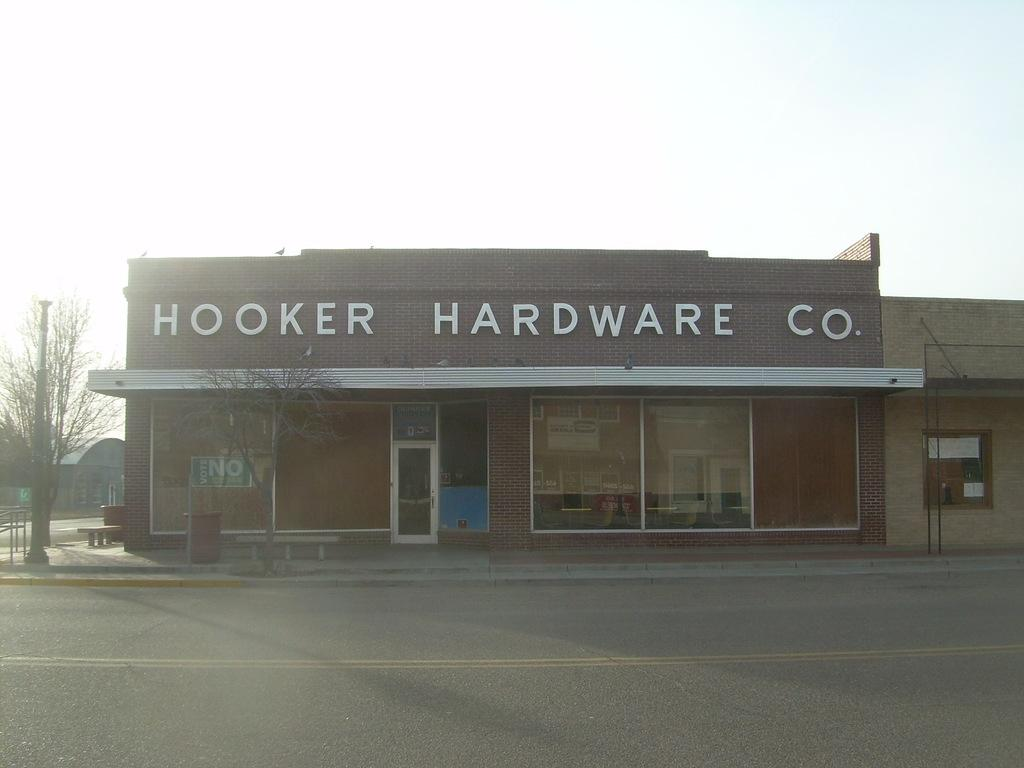What type of structures can be seen in the image? There are buildings in the image. Can you identify any specific details about one of the buildings? One of the buildings has a name on it. What type of vegetation is present in the image? There are trees in the image. What type of pathway is visible in the image? There is a road in the image. What part of the natural environment is visible in the image? The sky is visible in the image. Can you tell me how many cobwebs are present in the image? There are no cobwebs present in the image. What color is the range in the image? There is no range present in the image. 